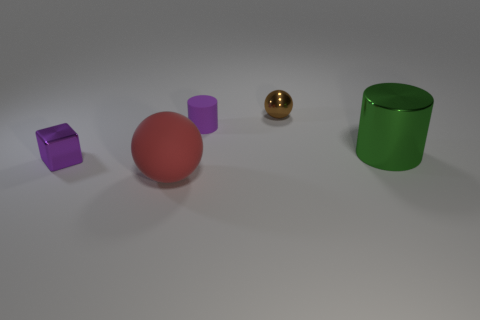There is a sphere that is in front of the tiny metal object that is in front of the big green cylinder; what color is it?
Your answer should be compact. Red. There is a rubber object in front of the object to the right of the tiny metal thing that is right of the small shiny block; what is its shape?
Your response must be concise. Sphere. How many tiny brown balls are made of the same material as the purple block?
Keep it short and to the point. 1. There is a small shiny object in front of the large green thing; how many green metallic things are in front of it?
Provide a succinct answer. 0. How many large things are there?
Your response must be concise. 2. Does the green cylinder have the same material as the purple thing that is on the right side of the small metallic block?
Your response must be concise. No. Do the cylinder behind the big green metal thing and the small metallic block have the same color?
Make the answer very short. Yes. The thing that is right of the tiny matte cylinder and in front of the brown ball is made of what material?
Ensure brevity in your answer.  Metal. What size is the rubber ball?
Your answer should be very brief. Large. There is a small metallic cube; is it the same color as the cylinder that is on the left side of the green cylinder?
Your answer should be very brief. Yes. 